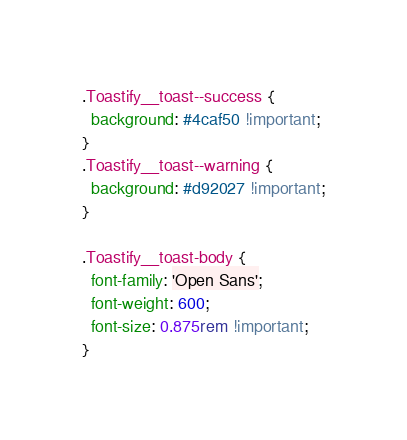Convert code to text. <code><loc_0><loc_0><loc_500><loc_500><_CSS_>.Toastify__toast--success {
  background: #4caf50 !important;
}
.Toastify__toast--warning {
  background: #d92027 !important;
}

.Toastify__toast-body {
  font-family: 'Open Sans';
  font-weight: 600;
  font-size: 0.875rem !important;
}
</code> 